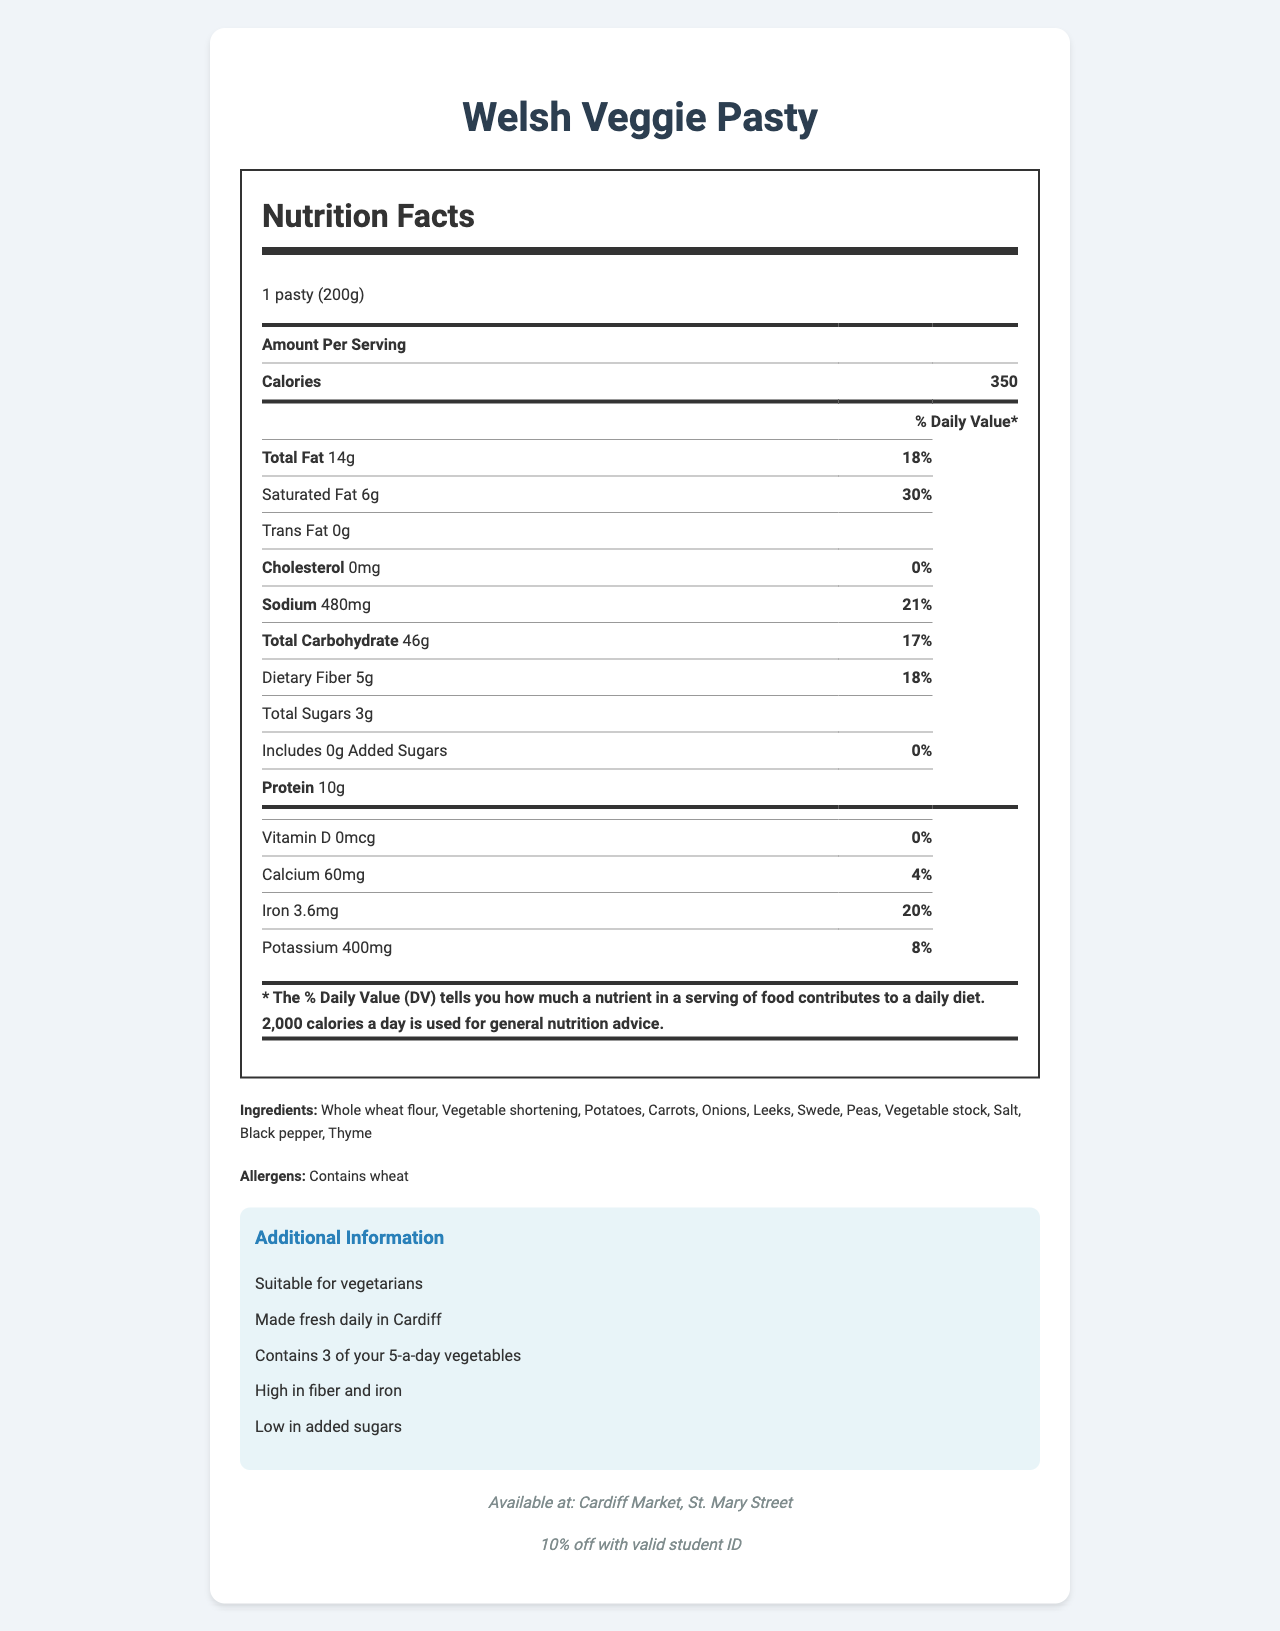what is the product name? The product name is clearly mentioned at the beginning of the document.
Answer: Welsh Veggie Pasty what is the serving size of the Welsh Veggie Pasty? The serving size is explicitly listed as "1 pasty (200g)."
Answer: 1 pasty (200g) how many calories are there per serving? The number of calories per serving is given as 350.
Answer: 350 what is the total amount of fat? The total fat amount is stated as "14g."
Answer: 14g how much dietary fiber does the Welsh Veggie Pasty have? The amount of dietary fiber is specified as "5g."
Answer: 5g where is this product available? The location where the product is available is stated as "Cardiff Market, St. Mary Street."
Answer: Cardiff Market, St. Mary Street Does the Welsh Veggie Pasty contain cholesterol? The cholesterol amount is listed as "0mg," meaning it does not contain cholesterol.
Answer: No what are the main ingredients? The ingredients are clearly listed in the document.
Answer: Whole wheat flour, Vegetable shortening, Potatoes, Carrots, Onions, Leeks, Swede, Peas, Vegetable stock, Salt, Black pepper, Thyme what daily value percentage of iron does the Welsh Veggie Pasty provide? The daily value percentage for iron is mentioned as "20%."
Answer: 20% is the Welsh Veggie Pasty suitable for vegetarians? The additional information section states that it is "Suitable for vegetarians."
Answer: Yes what is the sodium content per serving? A. 200mg B. 480mg C. 350mg D. 600mg The sodium content per serving is stated as "480mg," which corresponds to option B.
Answer: B which of the following is not an ingredient in the Welsh Veggie Pasty? A. Kale B. Potatoes C. Onions D. Carrots Kale is not listed among the ingredients, making it the correct answer.
Answer: A is the food item high in added sugars? The added sugars are listed as 0g, and the additional info mentions it is low in added sugars.
Answer: No how much protein does one serving provide? The protein content per serving is listed as "10g."
Answer: 10g summarize the main nutritional benefits of the Welsh Veggie Pasty. The document highlights that the pasty is suitable for vegetarians, high in fiber and iron, low in added sugars, and made with fresh, wholesome ingredients. It also offers a student discount and contributes to the daily vegetable intake.
Answer: The Welsh Veggie Pasty is a vegetarian-friendly option that is high in dietary fiber and iron, low in added sugars, and provides a balanced nutrient profile with 350 calories per serving. It contains a variety of vegetables contributing to 3 of your 5-a-day and offers 10% off with a valid student ID. what is the source of the vegetable stock in the ingredients? The document does not specify the source of the vegetable stock used in the ingredients.
Answer: Cannot be determined 